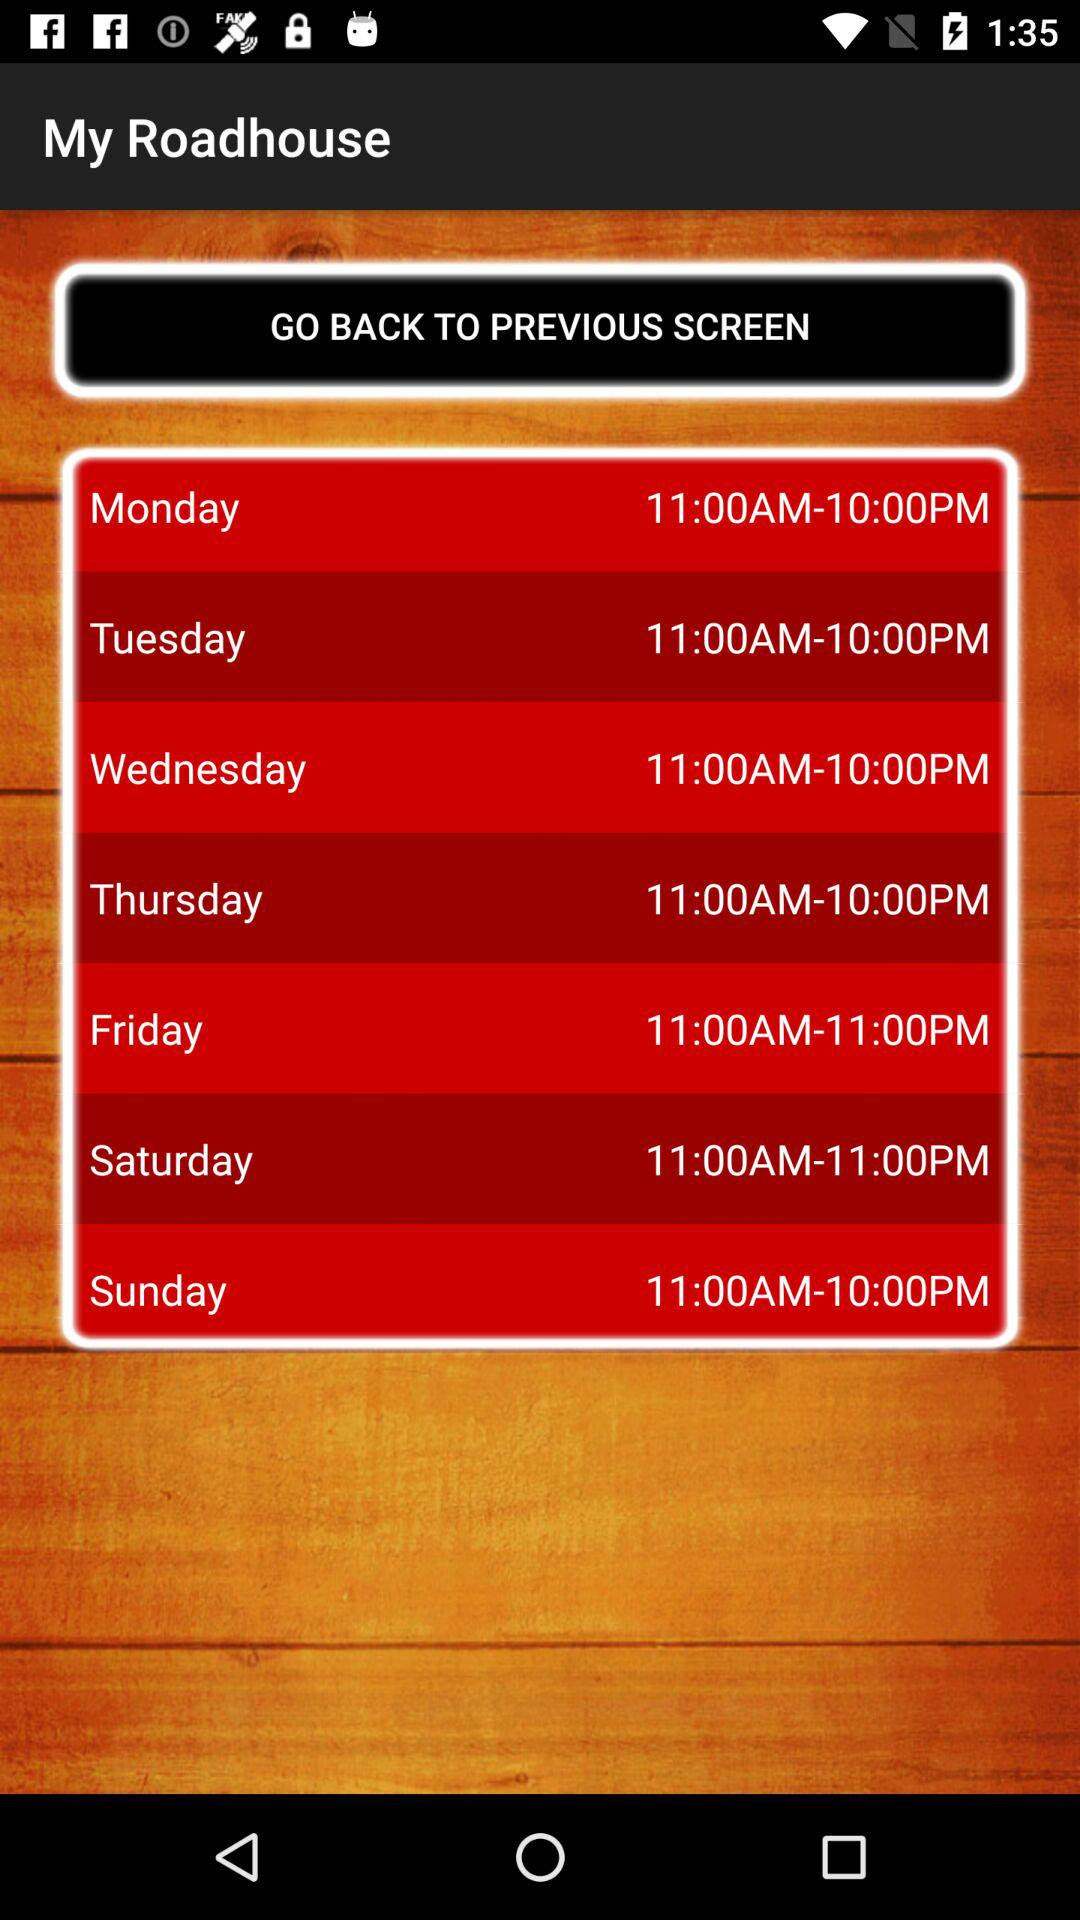What is the selected time period for Sunday? The selected time period is from 11:00 AM to 10:00 PM. 